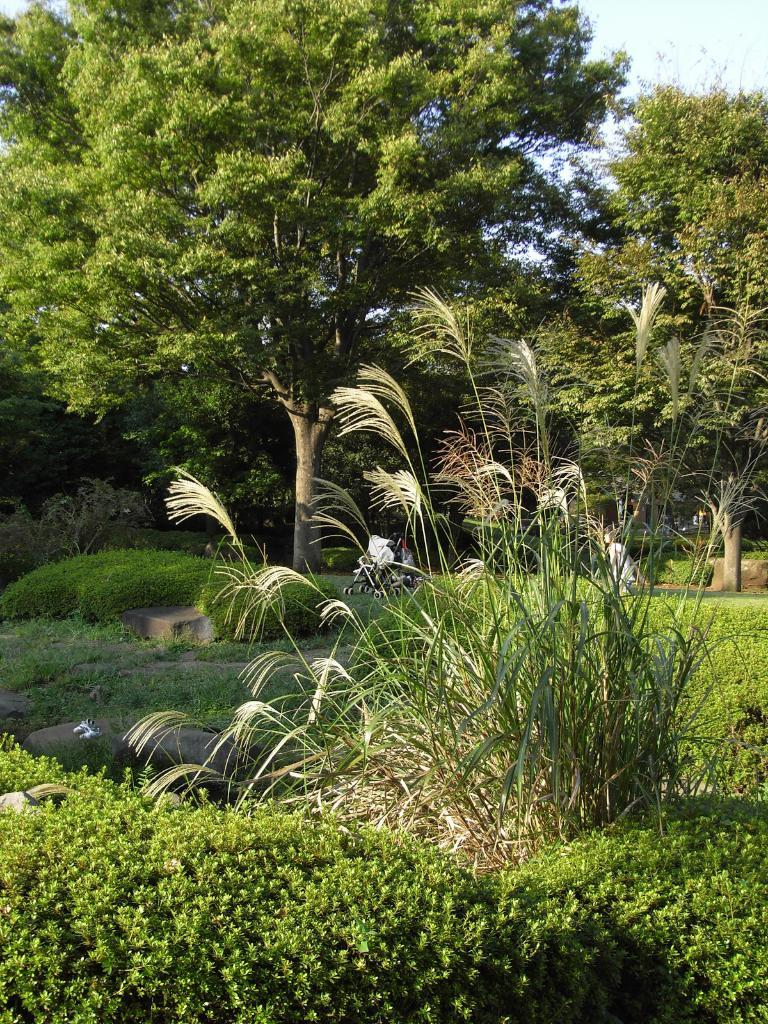What type of setting is depicted in the image? There is a garden in the image. What can be seen in the background of the garden? There are trees in the background of the image. What is visible beyond the trees in the image? The sky is visible in the background of the image. What type of straw is being used to stir the contents of the jar in the image? There is no jar or straw present in the image; it only features a garden with trees and the sky in the background. 